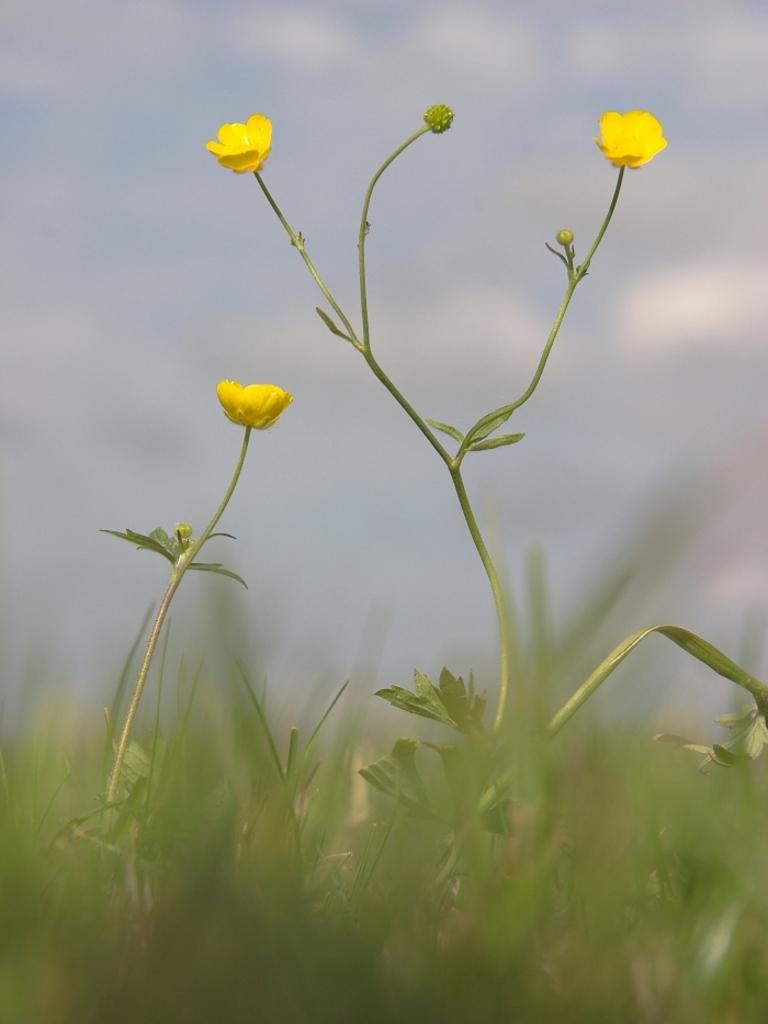How many yellow flowers can be seen in the image? There are three yellow flowers in the image. What else can be found among the flowers? There are leaves in the image. What type of vegetation is present in the image? There is grass in the image. What can be seen in the background of the image? There are clouds and the sky visible in the background of the image. How many chairs are placed on the bridge in the image? There is no bridge or chairs present in the image. 